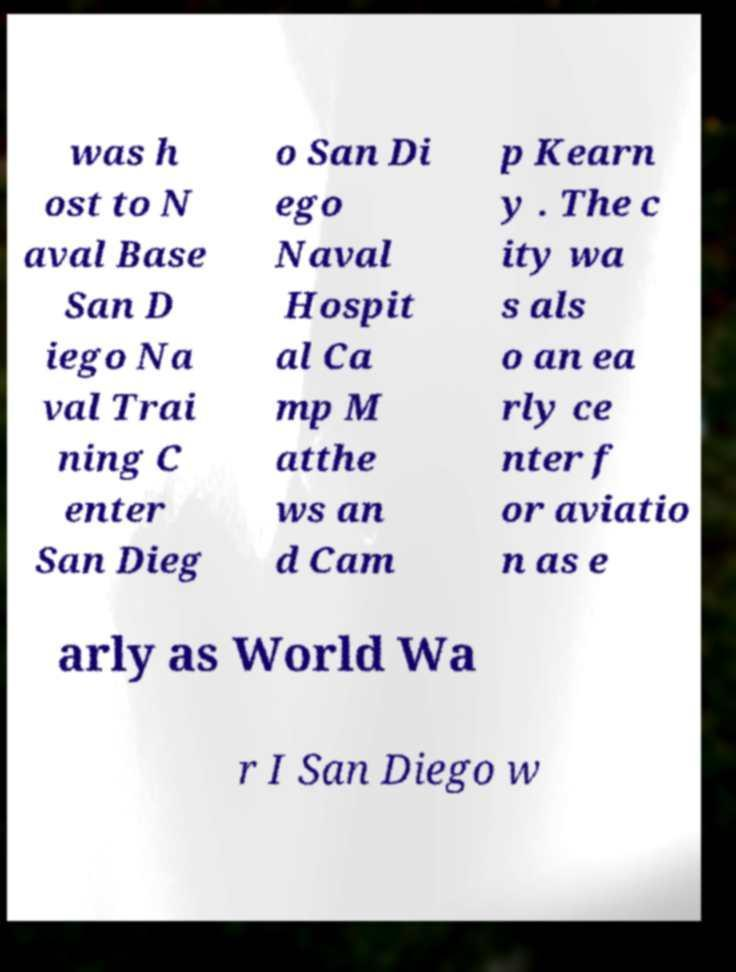Please read and relay the text visible in this image. What does it say? was h ost to N aval Base San D iego Na val Trai ning C enter San Dieg o San Di ego Naval Hospit al Ca mp M atthe ws an d Cam p Kearn y . The c ity wa s als o an ea rly ce nter f or aviatio n as e arly as World Wa r I San Diego w 